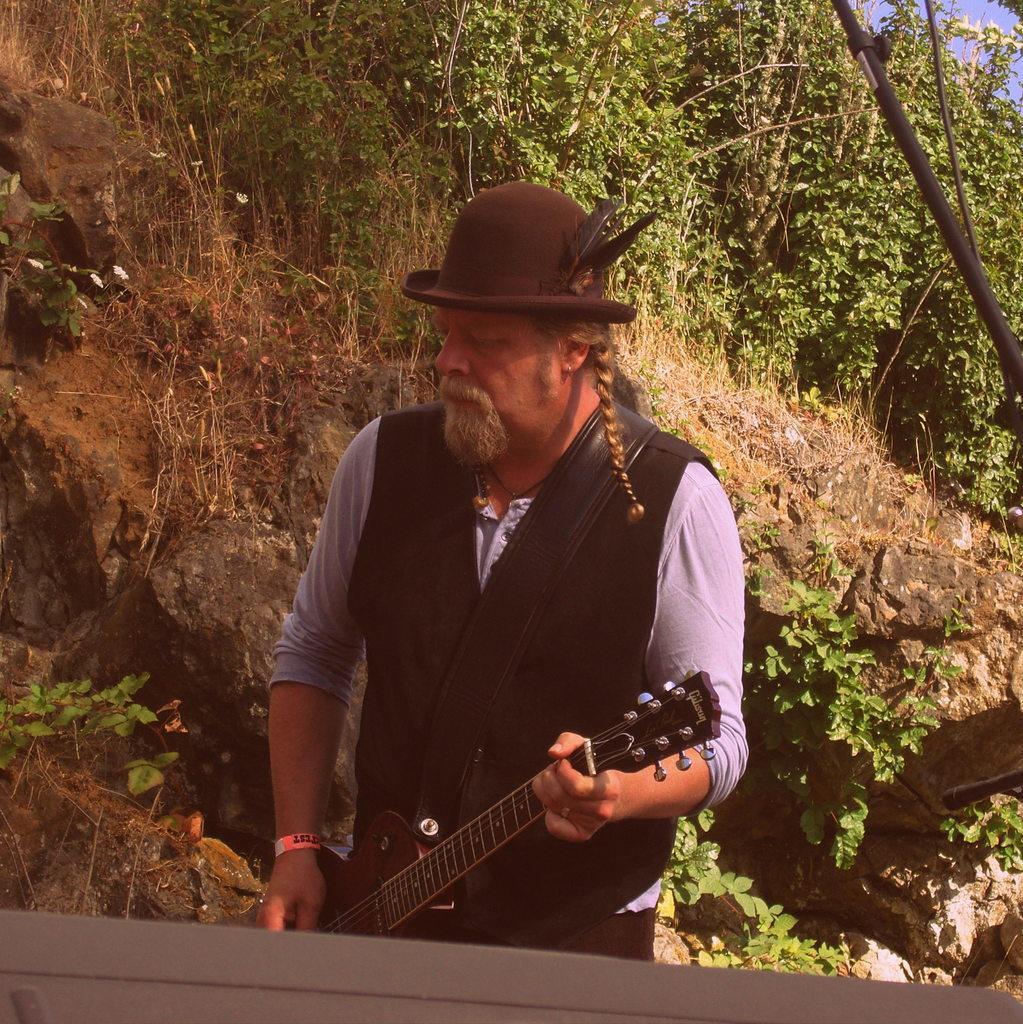Please provide a concise description of this image. A man with black jacket is standing and playing a guitar. On his head there is a cap. On the cap there are feathers. In the background there are many trees and rocks. 